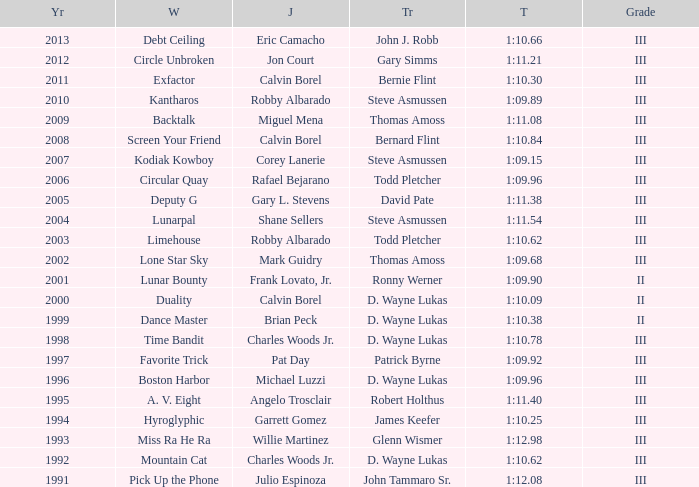Which trainer had a time of 1:10.09 with a year less than 2009? D. Wayne Lukas. 